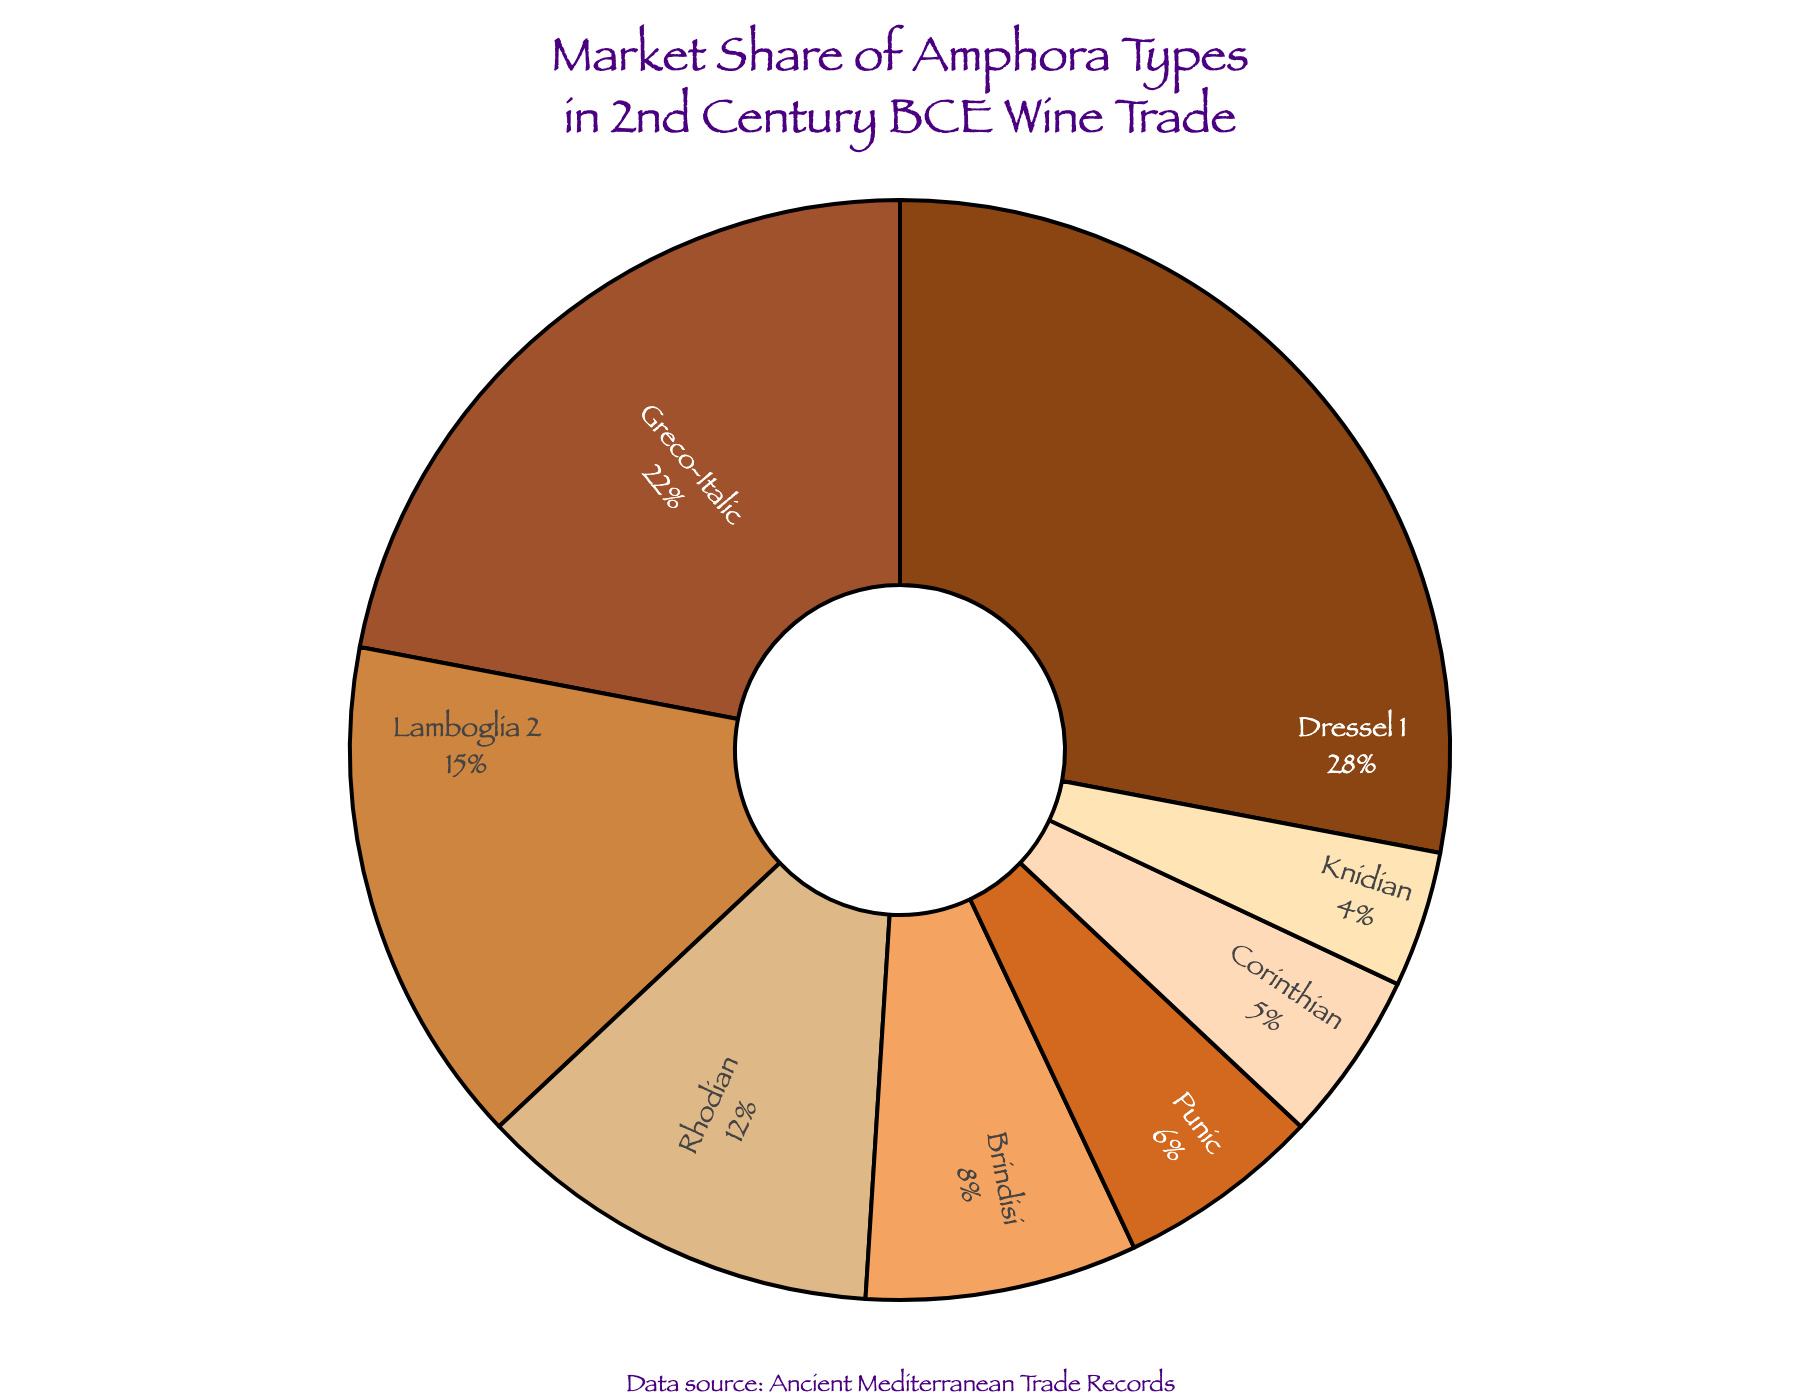Which amphora type has the largest market share in the wine trade of the 2nd century BCE? The largest segment in the pie chart belongs to the Dressel 1 type.
Answer: Dressel 1 What is the combined market share percentage of Greco-Italic and Rhodian amphoras? The market share of Greco-Italic amphoras is 22%, and Rhodian amphoras is 12%. Combined, this is 22 + 12 = 34%.
Answer: 34% Which amphora type has a market share closest to 10%? By looking at the pie chart, Brindisi amphora type has a market share of 8%, which is the closest to 10%.
Answer: Brindisi How does the market share of Punic amphoras compare to Knidian amphoras? The market share of Punic amphoras is 6%, whereas Knidian amphoras have a market share of 4%. Punic amphoras have a higher market share than Knidian.
Answer: Punic amphoras have a higher share What is the sum of the market shares of the three amphora types with the smallest market shares? The three types with the smallest market shares are Knidian (4%), Corinthian (5%), and Punic (6%). Summed up, this is 4 + 5 + 6 = 15%.
Answer: 15% Which color represents the Rhodian amphora type in the pie chart? In the pie chart, the Rhodian amphora type is represented by the fourth largest segment, which corresponds to a light brown color.
Answer: Light brown Is the market share of Lamboglia 2 amphoras greater than that of the combined market shares of Brindisi and Corinthian amphoras? Lamboglia 2 amphoras have a market share of 15%. Brindisi and Corinthian together have a market share of 8% + 5% = 13%. Lamboglia 2 has a greater market share.
Answer: Yes What is the average market share percentage of the top three amphora types? The top three amphora types are Dressel 1 (28%), Greco-Italic (22%), and Lamboglia 2 (15%). The average is (28 + 22 + 15) / 3 = 65 / 3 ≈ 21.67%.
Answer: 21.67% What percentage of the market do all amphora types not named Dressel 1 account for? The total market share of all amphoras is 100%. Excluding Dressel 1's 28%, the remaining share is 100 - 28 = 72%.
Answer: 72% 